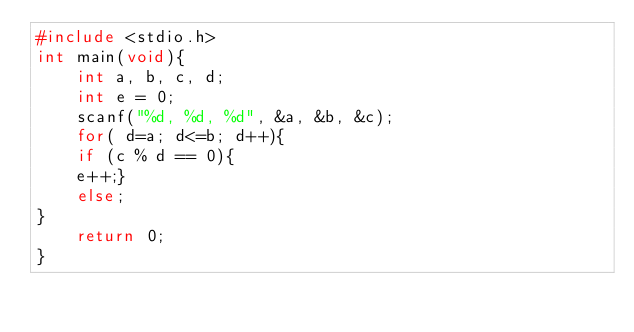Convert code to text. <code><loc_0><loc_0><loc_500><loc_500><_C_>#include <stdio.h>
int main(void){
    int a, b, c, d;
    int e = 0;
    scanf("%d, %d, %d", &a, &b, &c);
    for( d=a; d<=b; d++){
    if (c % d == 0){
    e++;}
    else;
}
    return 0;
}



</code> 